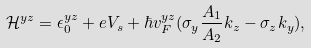Convert formula to latex. <formula><loc_0><loc_0><loc_500><loc_500>\mathcal { H } ^ { y z } = \epsilon _ { 0 } ^ { y z } + e V _ { s } + \hbar { v } _ { F } ^ { y z } ( \sigma _ { y } \frac { A _ { 1 } } { A _ { 2 } } k _ { z } - \sigma _ { z } k _ { y } ) ,</formula> 